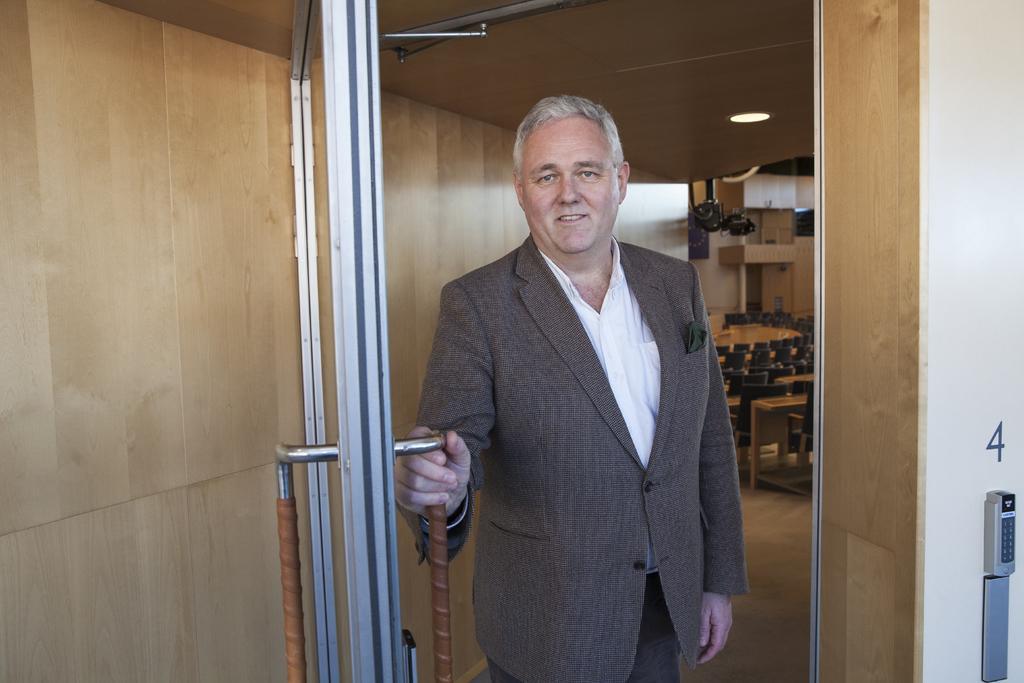Could you give a brief overview of what you see in this image? Here I can see a man wearing suit, standing, smiling and giving pose for the picture. He is holding a metal rod which is attached to the door. On the right and left sides of the image I can see the walls. In the background I can see few empty chairs on the floor. 